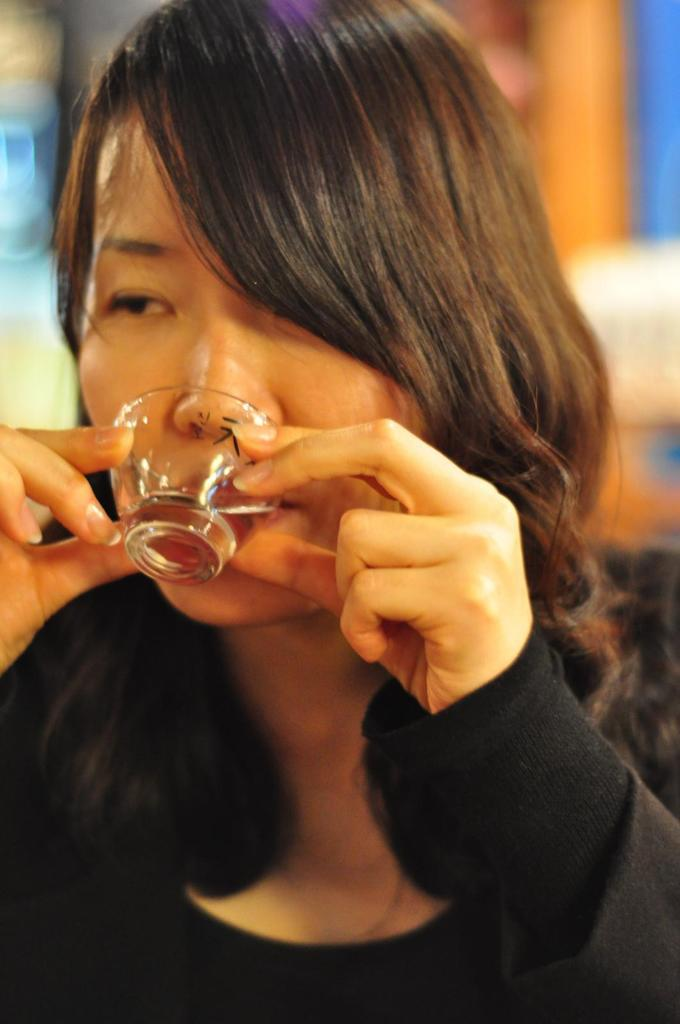Who is the main subject in the image? There is a lady in the image. What is the lady holding in the image? The lady is holding a glass. What is the lady doing with the glass? The lady is drinking from the glass. Can you describe the background of the image? The background of the image is blurred. What type of smoke can be seen coming from the glass in the image? There is no smoke present in the image; the lady is drinking from the glass. 